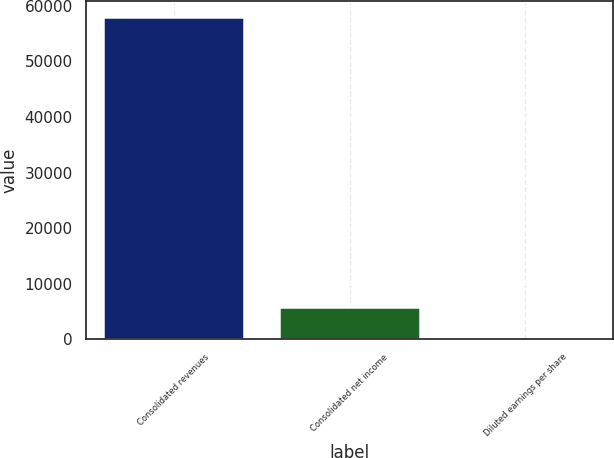<chart> <loc_0><loc_0><loc_500><loc_500><bar_chart><fcel>Consolidated revenues<fcel>Consolidated net income<fcel>Diluted earnings per share<nl><fcel>57899<fcel>5795.06<fcel>5.73<nl></chart> 